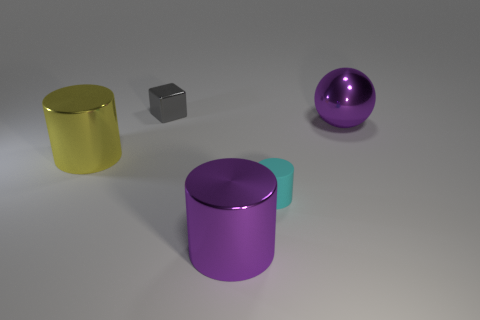Add 4 big cyan matte things. How many objects exist? 9 Subtract all cubes. How many objects are left? 4 Add 4 gray shiny objects. How many gray shiny objects are left? 5 Add 4 purple metal cylinders. How many purple metal cylinders exist? 5 Subtract 0 brown cylinders. How many objects are left? 5 Subtract all metal blocks. Subtract all purple metal objects. How many objects are left? 2 